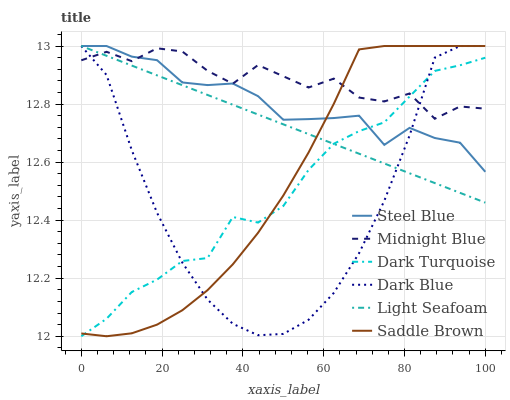Does Dark Turquoise have the minimum area under the curve?
Answer yes or no. No. Does Dark Turquoise have the maximum area under the curve?
Answer yes or no. No. Is Dark Turquoise the smoothest?
Answer yes or no. No. Is Dark Turquoise the roughest?
Answer yes or no. No. Does Steel Blue have the lowest value?
Answer yes or no. No. Does Dark Turquoise have the highest value?
Answer yes or no. No. 